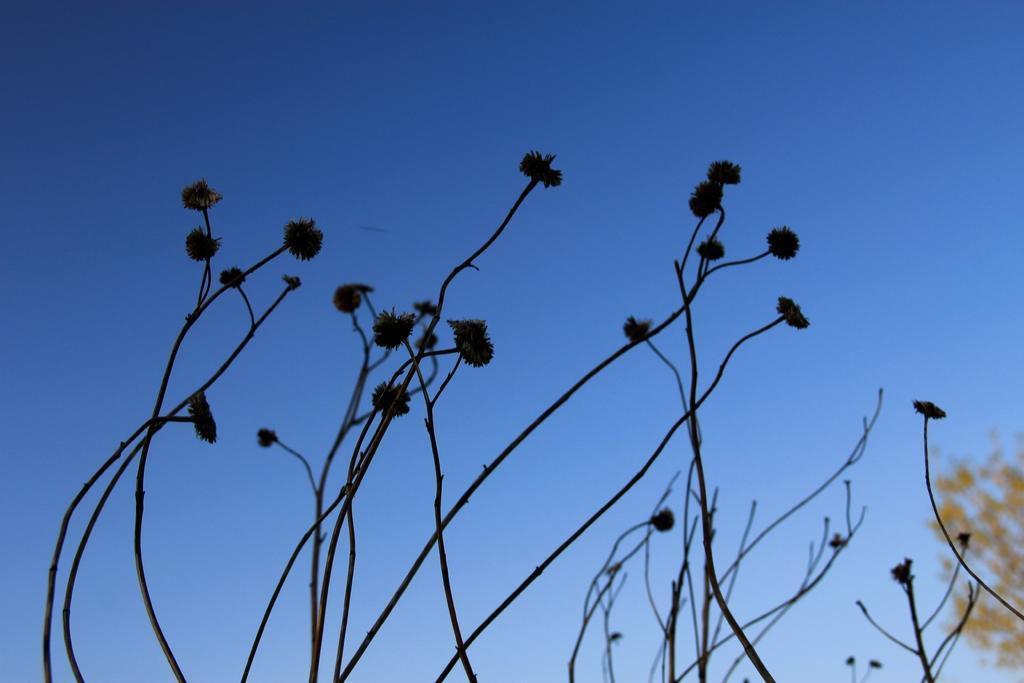Please provide a concise description of this image. In this image I can see few stems along with the flowers. At the top of the image, I can see the sky in blue color. 